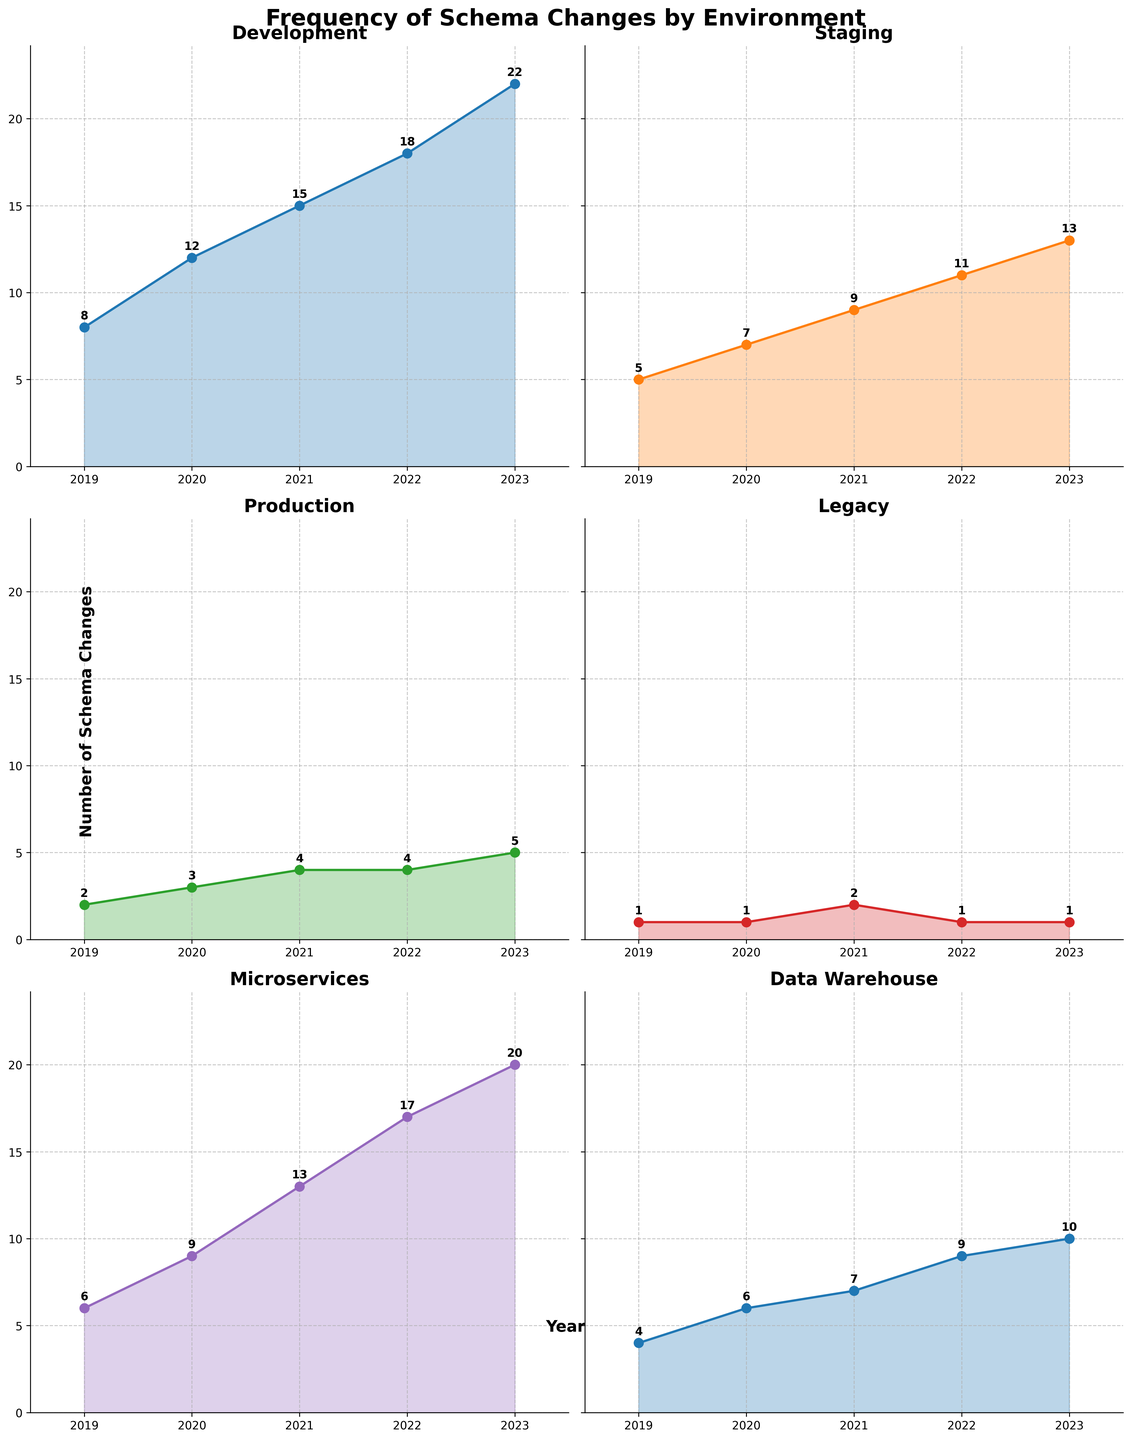What is the title of the figure? The title of the figure is displayed at the top in a bold and large font. It summarizes the content of the figure.
Answer: Frequency of Schema Changes by Environment How many environments are analyzed in the figure? The figure consists of multiple subplots, each representing a different environment. Counting them will provide the answer.
Answer: 6 In which environment did schema changes increase the most from 2019 to 2023? To find the environment with the greatest increase, subtract the 2019 value from the 2023 value for each environment and identify the largest difference.
Answer: Development Which environments have a steady rate of schema changes, with little variation over years? Look at the subplots with almost flat lines. These lines represent environments with minimal changes year over year.
Answer: Legacy What is the combined number of schema changes in the Development environment for the years 2021 and 2022? By adding the values for 2021 and 2022 in the Development subplot, we get the total number of schema changes for those two years.
Answer: 33 Which environment had the highest number of schema changes in 2022? Locate the year 2022 on the x-axis for each subplot and identify the highest value among them.
Answer: Development How did the number of schema changes in the Microservices environment change from 2019 to 2021? Subtract the value for 2019 from the value for 2021 in the Microservices subplot.
Answer: Increased by 7 Was there an increase or decrease in schema changes in the Production environment between 2021 and 2022? Look at the values for 2021 and 2022 in the Production subplot to ascertain if there was a rise or fall.
Answer: No change Compare the total number of schema changes in the Staging and Data Warehouse environments from 2019 to 2023. Sum up the values from 2019 to 2023 for both Staging and Data Warehouse and compare the totals.
Answer: Staging: 45, Data Warehouse: 36 Which environment had the same number of schema changes for two consecutive years and what are those years? Find any subplot where the value does not change between two consecutive years and note the years.
Answer: Production, 2021-2022 